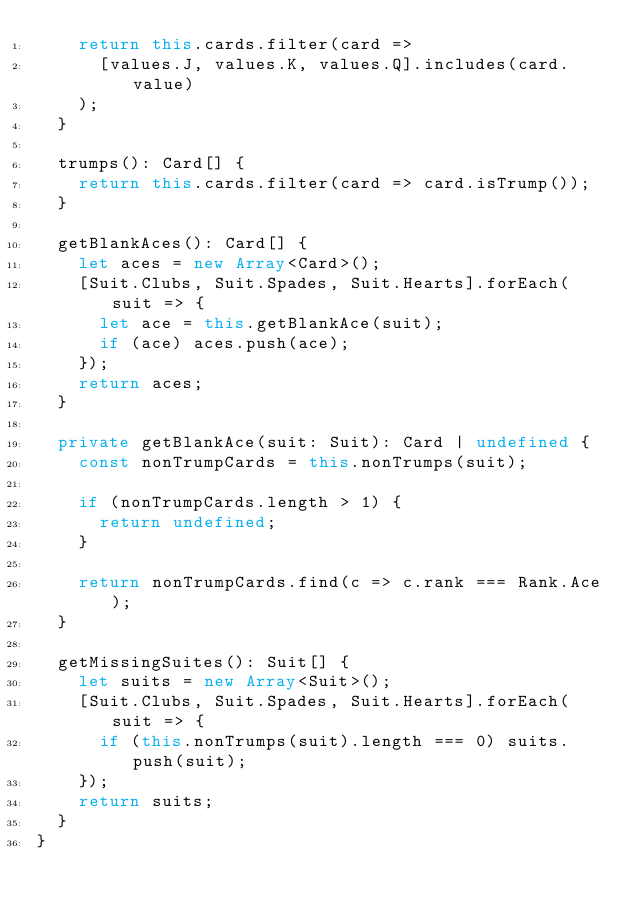Convert code to text. <code><loc_0><loc_0><loc_500><loc_500><_TypeScript_>    return this.cards.filter(card =>
      [values.J, values.K, values.Q].includes(card.value)
    );
  }

  trumps(): Card[] {
    return this.cards.filter(card => card.isTrump());
  }

  getBlankAces(): Card[] {
    let aces = new Array<Card>();
    [Suit.Clubs, Suit.Spades, Suit.Hearts].forEach(suit => {
      let ace = this.getBlankAce(suit);
      if (ace) aces.push(ace);
    });
    return aces;
  }

  private getBlankAce(suit: Suit): Card | undefined {
    const nonTrumpCards = this.nonTrumps(suit);

    if (nonTrumpCards.length > 1) {
      return undefined;
    }

    return nonTrumpCards.find(c => c.rank === Rank.Ace);
  }

  getMissingSuites(): Suit[] {
    let suits = new Array<Suit>();
    [Suit.Clubs, Suit.Spades, Suit.Hearts].forEach(suit => {
      if (this.nonTrumps(suit).length === 0) suits.push(suit);
    });
    return suits;
  }
}
</code> 